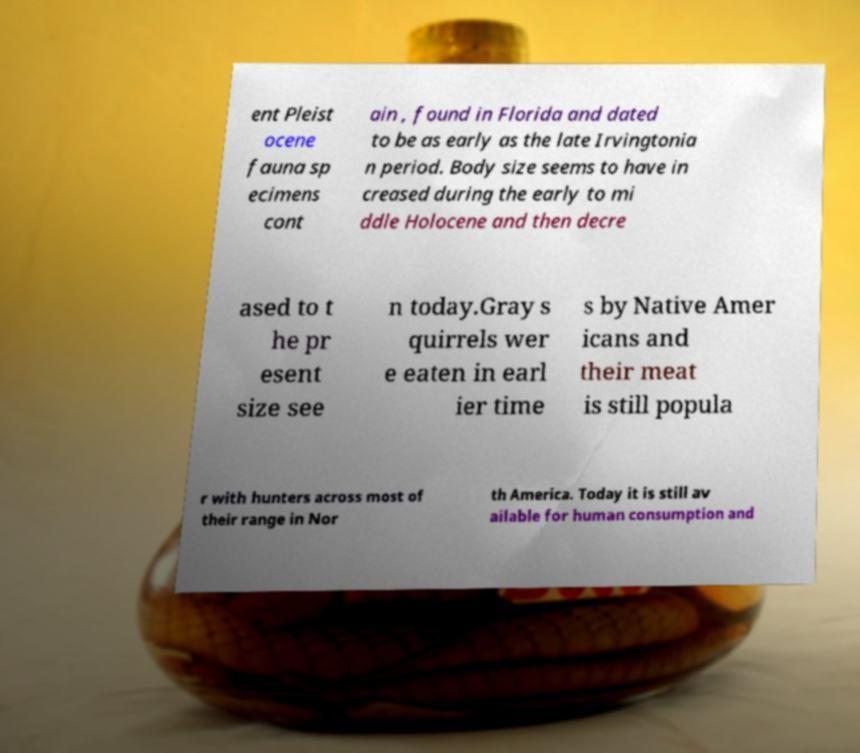For documentation purposes, I need the text within this image transcribed. Could you provide that? ent Pleist ocene fauna sp ecimens cont ain , found in Florida and dated to be as early as the late Irvingtonia n period. Body size seems to have in creased during the early to mi ddle Holocene and then decre ased to t he pr esent size see n today.Gray s quirrels wer e eaten in earl ier time s by Native Amer icans and their meat is still popula r with hunters across most of their range in Nor th America. Today it is still av ailable for human consumption and 